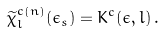<formula> <loc_0><loc_0><loc_500><loc_500>\widetilde { \chi } ^ { c ( n ) } _ { l } ( \epsilon _ { s } ) = K ^ { c } ( \epsilon , l ) \, .</formula> 